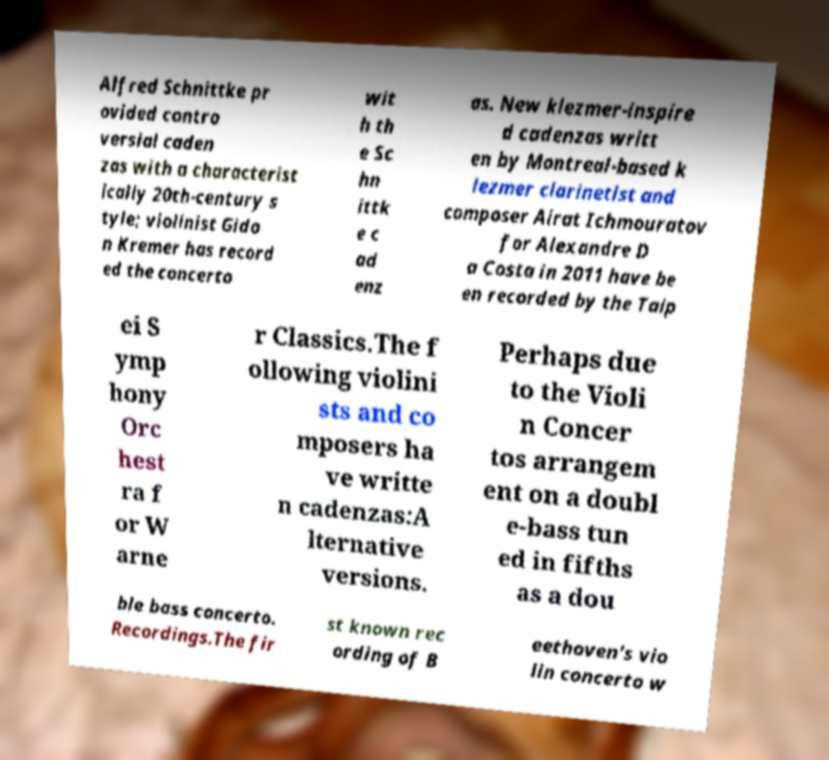Can you accurately transcribe the text from the provided image for me? Alfred Schnittke pr ovided contro versial caden zas with a characterist ically 20th-century s tyle; violinist Gido n Kremer has record ed the concerto wit h th e Sc hn ittk e c ad enz as. New klezmer-inspire d cadenzas writt en by Montreal-based k lezmer clarinetist and composer Airat Ichmouratov for Alexandre D a Costa in 2011 have be en recorded by the Taip ei S ymp hony Orc hest ra f or W arne r Classics.The f ollowing violini sts and co mposers ha ve writte n cadenzas:A lternative versions. Perhaps due to the Violi n Concer tos arrangem ent on a doubl e-bass tun ed in fifths as a dou ble bass concerto. Recordings.The fir st known rec ording of B eethoven's vio lin concerto w 